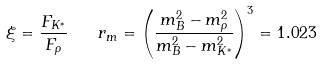<formula> <loc_0><loc_0><loc_500><loc_500>\xi = \frac { F _ { K ^ { * } } } { F _ { \rho } } \quad r _ { m } = \left ( \frac { m _ { B } ^ { 2 } - m _ { \rho } ^ { 2 } } { m _ { B } ^ { 2 } - m _ { K ^ { * } } ^ { 2 } } \right ) ^ { 3 } = 1 . 0 2 3</formula> 